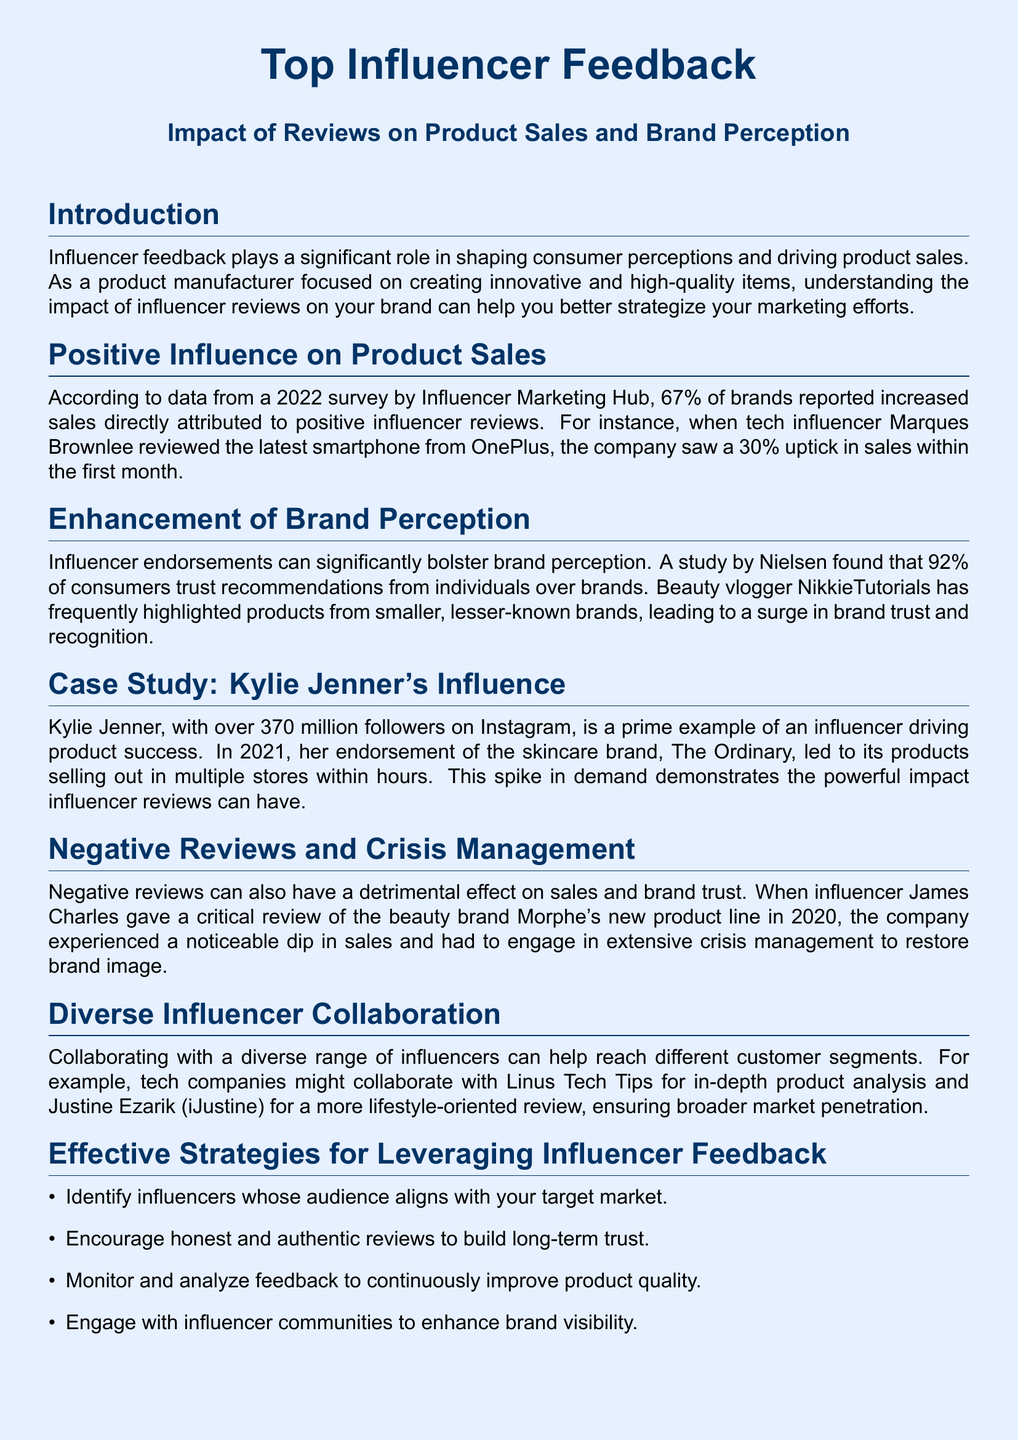What percentage of brands reported increased sales due to positive influencer reviews? The document states that 67% of brands reported increased sales attributed to positive influencer reviews.
Answer: 67% Who reviewed the latest smartphone from OnePlus? The document mentions tech influencer Marques Brownlee as having reviewed the latest smartphone from OnePlus.
Answer: Marques Brownlee What year was the study by Nielsen conducted that found consumer trust in recommendations? The document does not specify the year of the Nielsen study, but it is implied that it is recent and relevant to the current context.
Answer: Not specified What is the follower count of Kylie Jenner? The document states that Kylie Jenner has over 370 million followers on Instagram.
Answer: 370 million Which influencer gave a critical review of Morphe’s product line? The document specifies that influencer James Charles gave a critical review of Morphe's new product line.
Answer: James Charles What percentage of consumers trust recommendations from individuals over brands? According to the document, 92% of consumers trust recommendations from individuals over brands.
Answer: 92% Which strategies are suggested for leveraging influencer feedback? The document lists several strategies, including identifying aligned influencers, encouraging authentic reviews, monitoring feedback, and engaging communities.
Answer: Identify influencers What was the outcome of Kylie Jenner's endorsement for The Ordinary? The document notes that The Ordinary's products sold out in multiple stores within hours following Kylie Jenner's endorsement.
Answer: Sold out Why did Morphe engage in crisis management? The document indicates that Morphe experienced a dip in sales due to a negative review by James Charles, prompting crisis management efforts.
Answer: Negative review What is the main topic of the document? The document focuses on the impact of influencer reviews on product sales and brand perception.
Answer: Impact of Reviews 